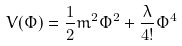<formula> <loc_0><loc_0><loc_500><loc_500>V ( \Phi ) = \frac { 1 } { 2 } m ^ { 2 } \Phi ^ { 2 } + \frac { \lambda } { 4 ! } \Phi ^ { 4 }</formula> 